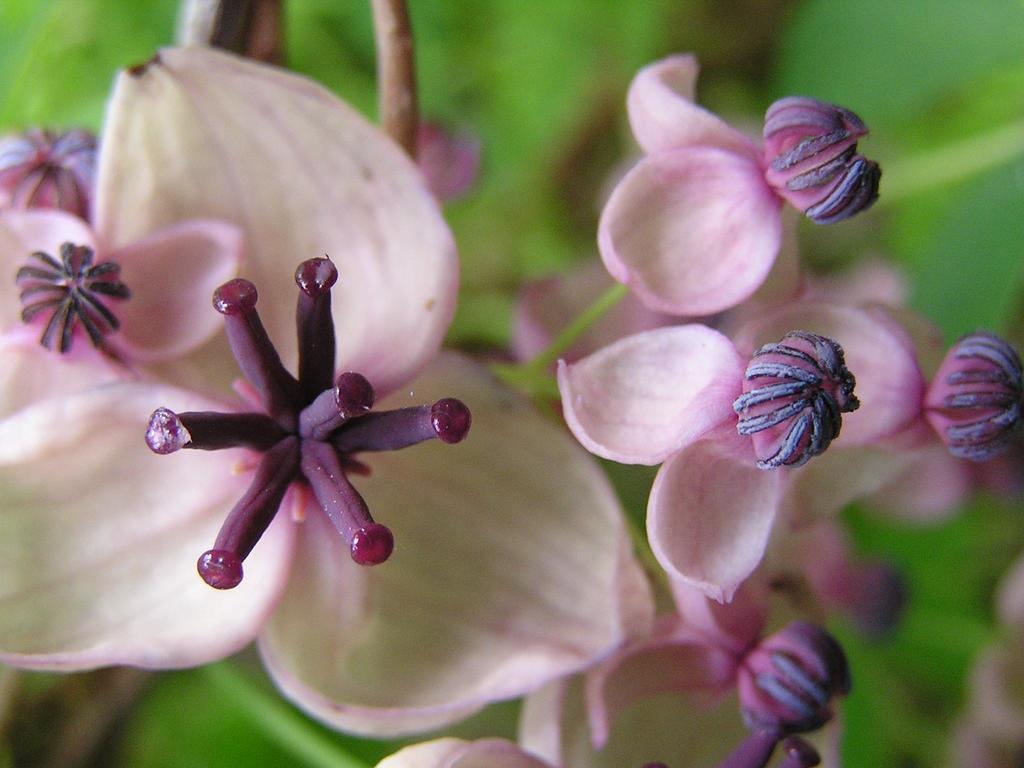Could you give a brief overview of what you see in this image? In this picture I can see there are flowers with pink color petals and buds and in the backdrop there are leafs. 